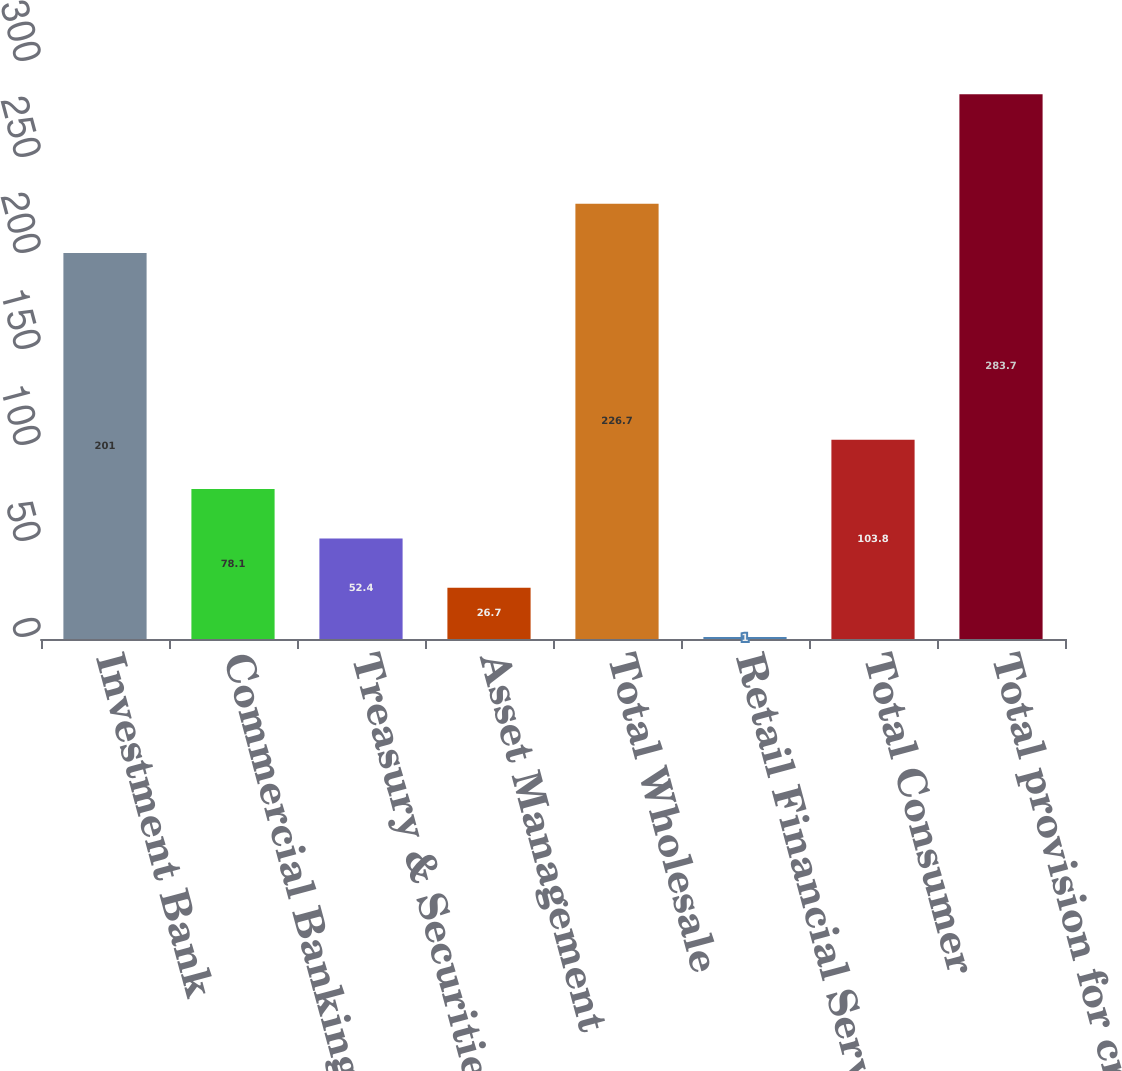Convert chart to OTSL. <chart><loc_0><loc_0><loc_500><loc_500><bar_chart><fcel>Investment Bank<fcel>Commercial Banking<fcel>Treasury & Securities Services<fcel>Asset Management<fcel>Total Wholesale<fcel>Retail Financial Services<fcel>Total Consumer<fcel>Total provision for credit<nl><fcel>201<fcel>78.1<fcel>52.4<fcel>26.7<fcel>226.7<fcel>1<fcel>103.8<fcel>283.7<nl></chart> 